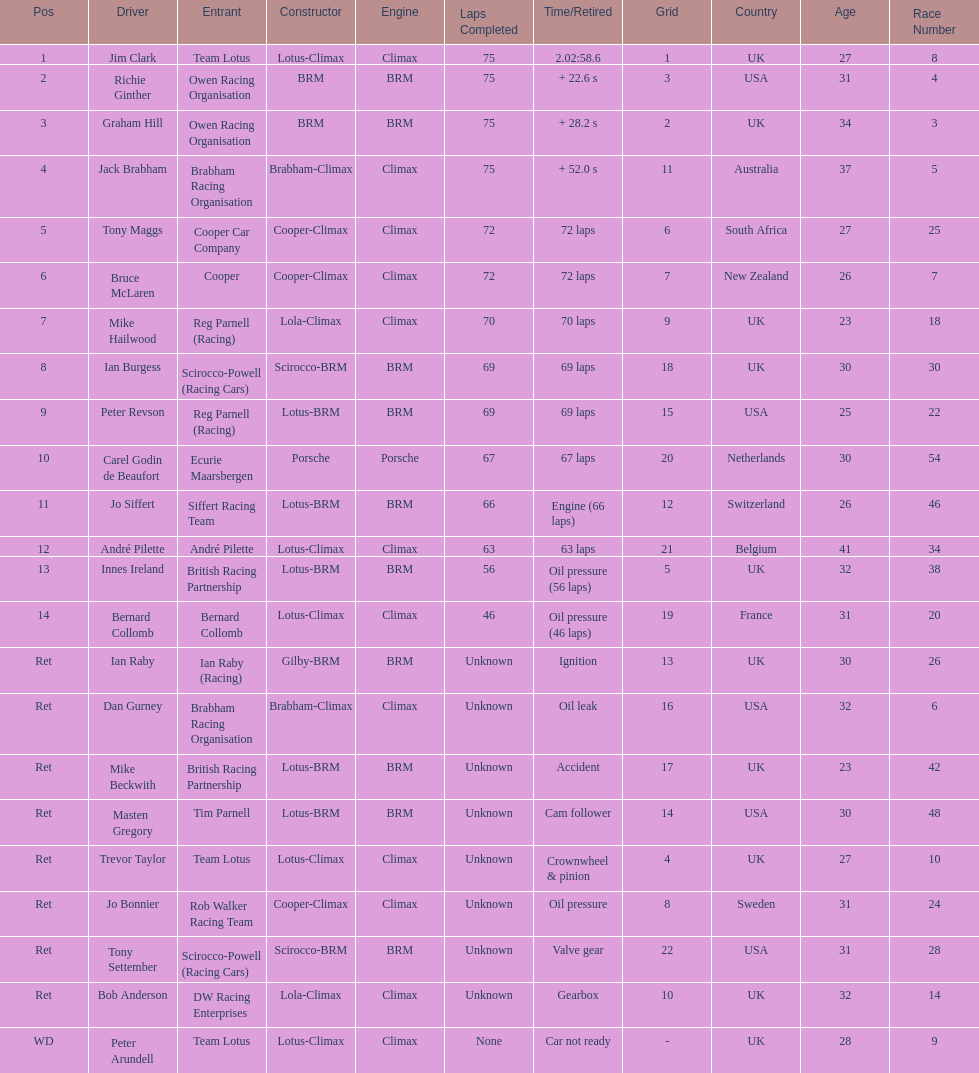Who was the top finisher that drove a cooper-climax? Tony Maggs. 